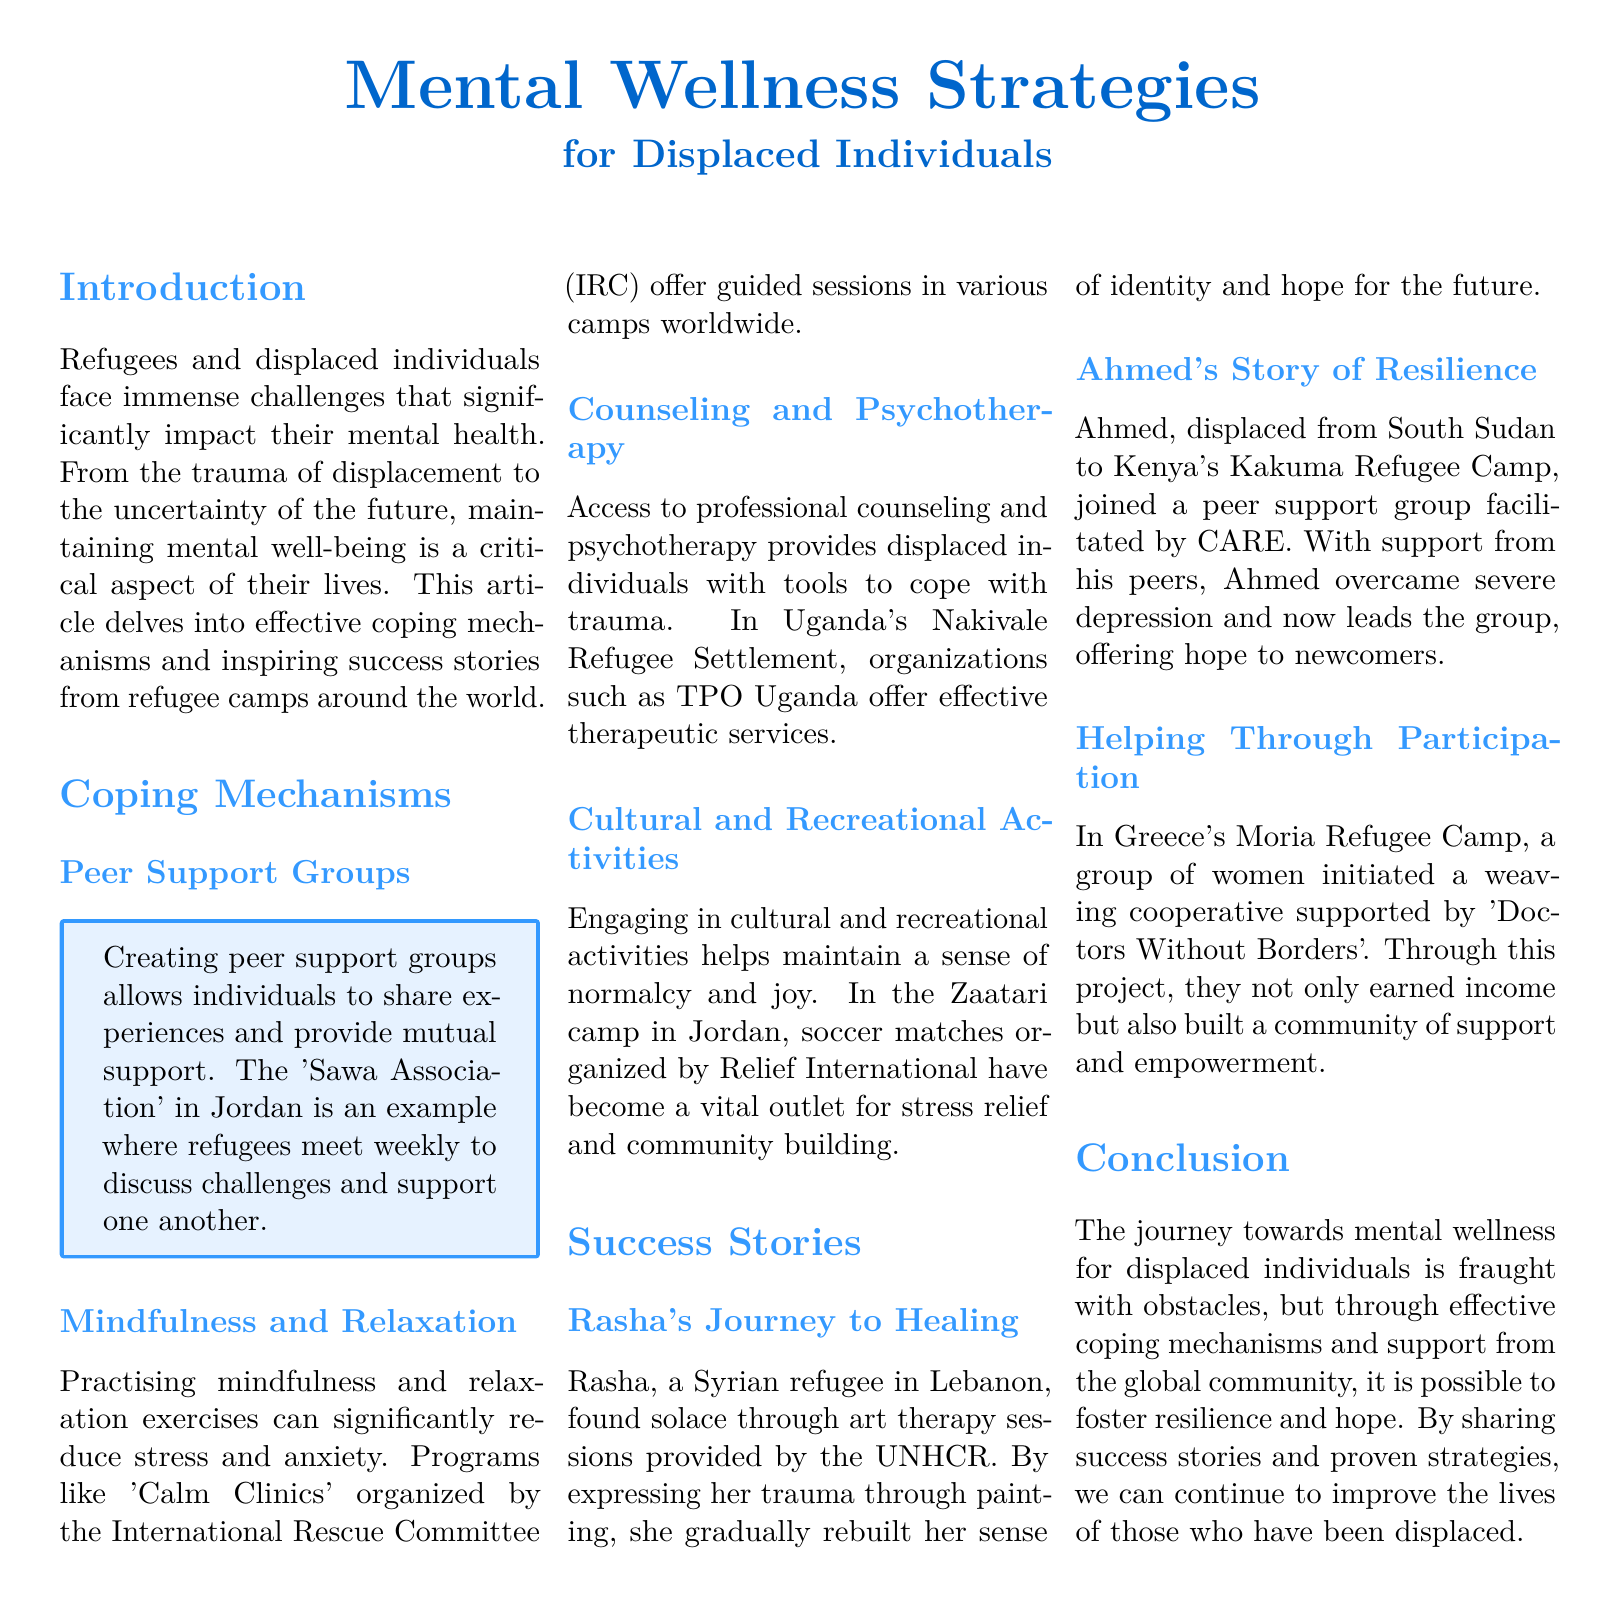What is the name of the peer support group in Jordan? The document mentions 'Sawa Association' as a peer support group in Jordan that helps refugees share experiences and support each other.
Answer: Sawa Association What mental wellness strategy reduces stress and anxiety? The article discusses mindfulness and relaxation exercises as a key strategy to reduce stress and anxiety among displaced individuals.
Answer: Mindfulness and relaxation Which organization offers counseling services in Uganda's Nakivale Refugee Settlement? The document states that TPO Uganda provides professional counseling and psychotherapy services to displaced individuals in Nakivale.
Answer: TPO Uganda What type of activity helped Rasha express her trauma? The success story of Rasha highlights her participation in art therapy sessions, which enabled her to express her trauma through painting.
Answer: Art therapy How did Ahmed contribute to his peer support group? The article indicates that Ahmed overcame depression and now leads the peer support group, thereby offering hope to other newcomers in his camp.
Answer: Leads the group What cooperative project was initiated by women in Greece's Moria Refugee Camp? The document describes a weaving cooperative that was initiated by a group of women in the Moria Refugee Camp, supported by 'Doctors Without Borders'.
Answer: Weaving cooperative What is the main theme discussed in this article? The document primarily focuses on mental wellness strategies for displaced individuals and shares coping mechanisms and success stories from various refugee camps.
Answer: Mental wellness strategies Which organization organized 'Calm Clinics' worldwide? According to the text, the International Rescue Committee (IRC) organizes 'Calm Clinics' that provide guided mindfulness sessions in various camps.
Answer: International Rescue Committee What is a crucial aspect of life for refugees, according to the introduction? The introduction emphasizes that maintaining mental well-being is a critical aspect of the lives of displaced individuals facing numerous challenges.
Answer: Mental well-being 